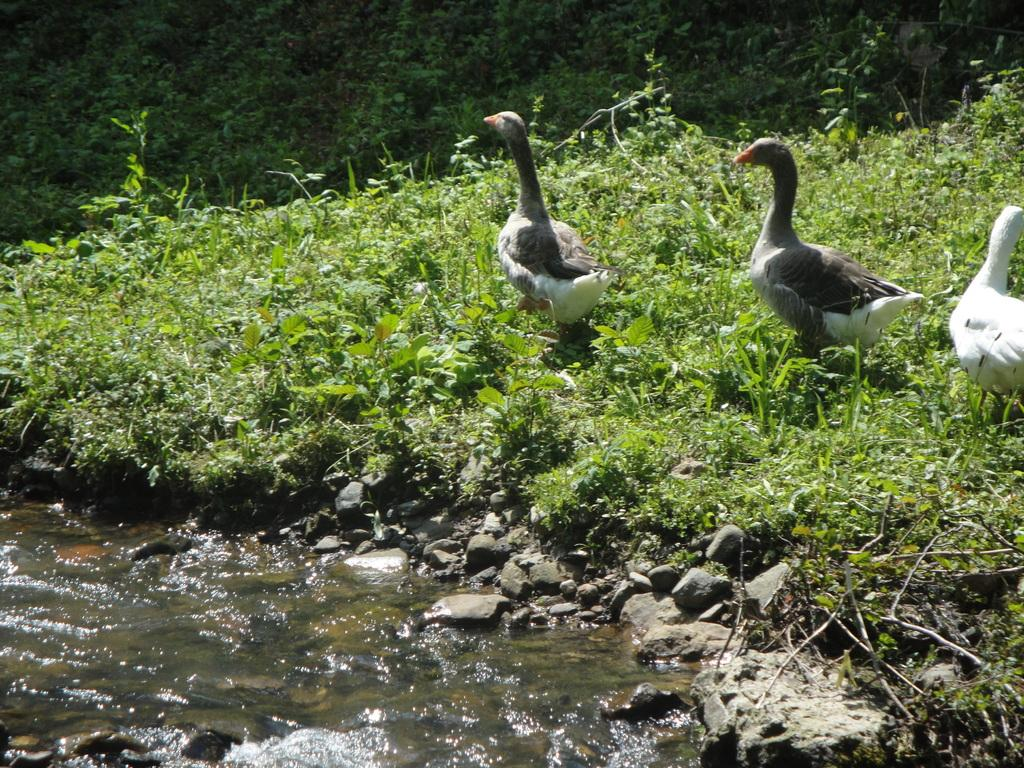What is the primary element present in the image? There is water in the image. What other objects can be seen in the image? There are stones and 3 ducks in the image. What are the ducks doing in the image? The ducks are walking on plants. Can you describe the environment in the image? The environment consists of water, stones, and plants. What type of balloon can be seen floating above the ducks in the image? There is no balloon present in the image. How does the environment in the image affect the acoustics of the area? The provided facts do not give information about the acoustics of the environment. Is there a spring visible in the image? There is no mention of a spring in the given facts. 